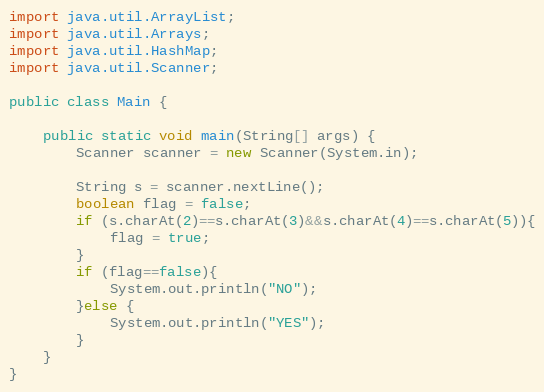Convert code to text. <code><loc_0><loc_0><loc_500><loc_500><_Java_>import java.util.ArrayList;
import java.util.Arrays;
import java.util.HashMap;
import java.util.Scanner;

public class Main {

    public static void main(String[] args) {
        Scanner scanner = new Scanner(System.in);

        String s = scanner.nextLine();
        boolean flag = false;
        if (s.charAt(2)==s.charAt(3)&&s.charAt(4)==s.charAt(5)){
            flag = true;
        }
        if (flag==false){
            System.out.println("NO");
        }else {
            System.out.println("YES");
        }
    }
}
</code> 